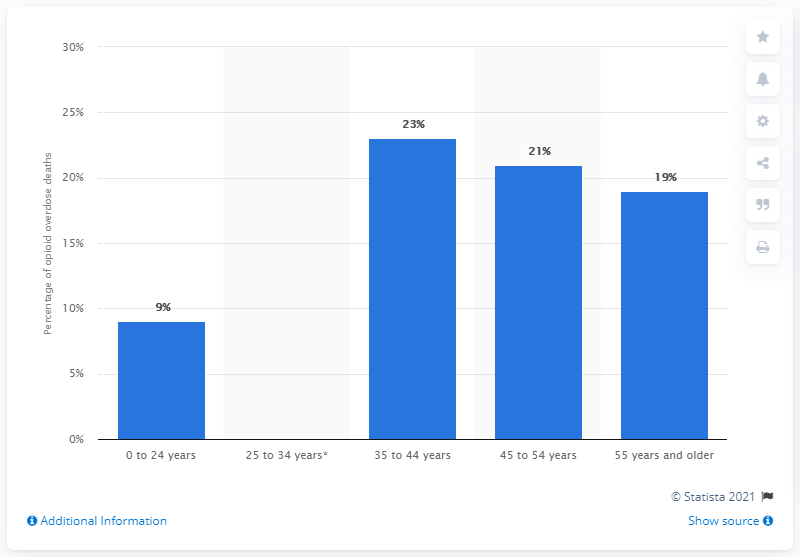Mention a couple of crucial points in this snapshot. In 2017, approximately 23% of all opioid overdose deaths in the United States occurred among individuals between the ages of 35 and 44. 